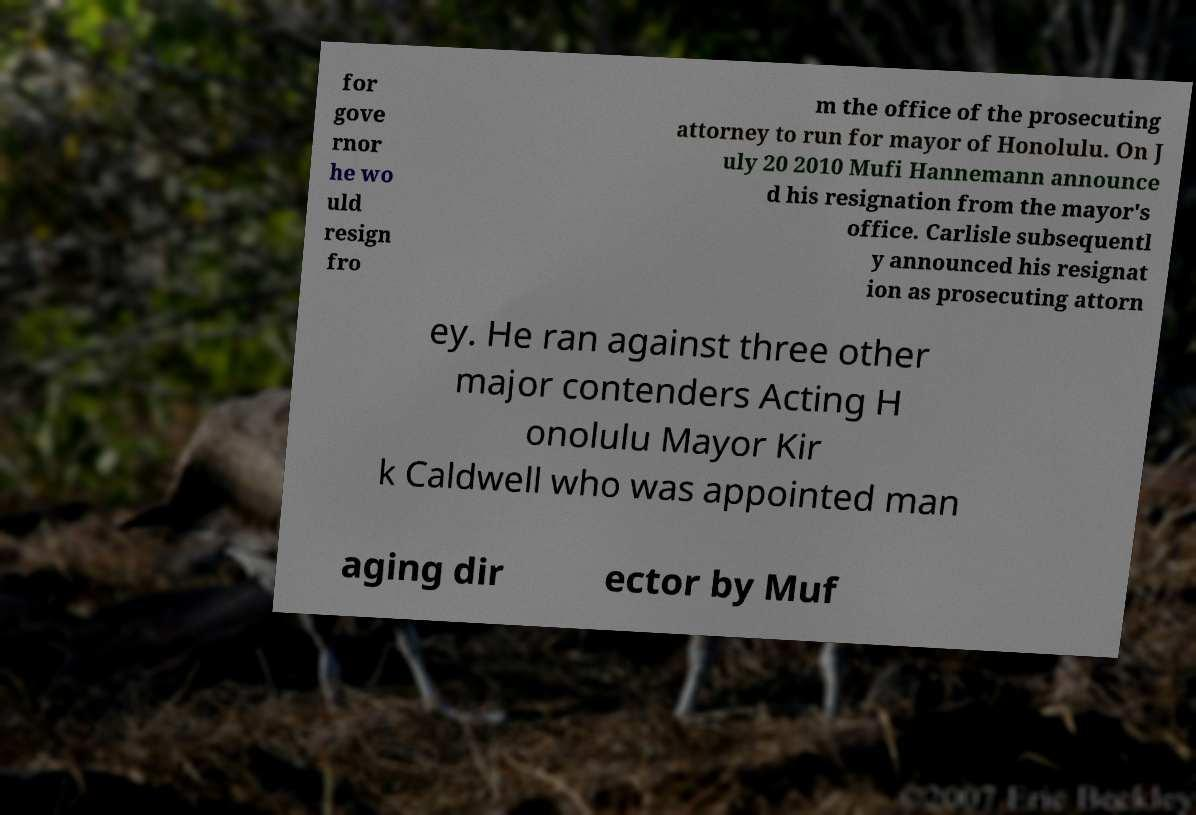What messages or text are displayed in this image? I need them in a readable, typed format. for gove rnor he wo uld resign fro m the office of the prosecuting attorney to run for mayor of Honolulu. On J uly 20 2010 Mufi Hannemann announce d his resignation from the mayor's office. Carlisle subsequentl y announced his resignat ion as prosecuting attorn ey. He ran against three other major contenders Acting H onolulu Mayor Kir k Caldwell who was appointed man aging dir ector by Muf 